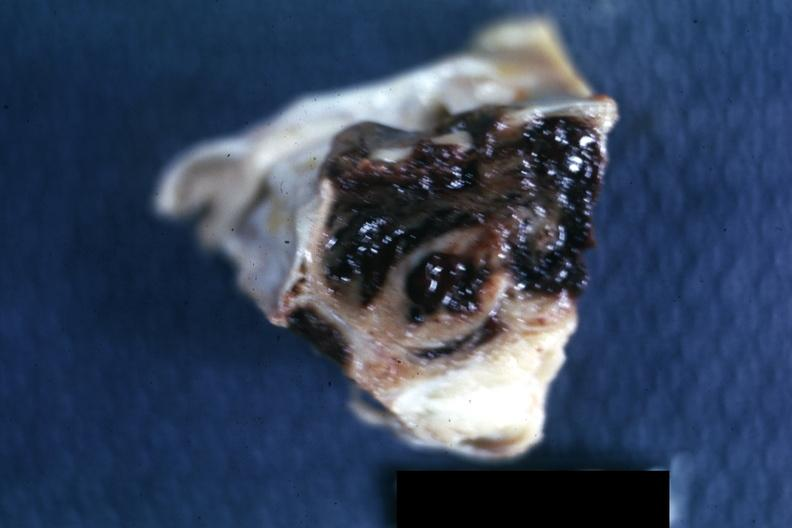s chromophobe adenoma present?
Answer the question using a single word or phrase. Yes 